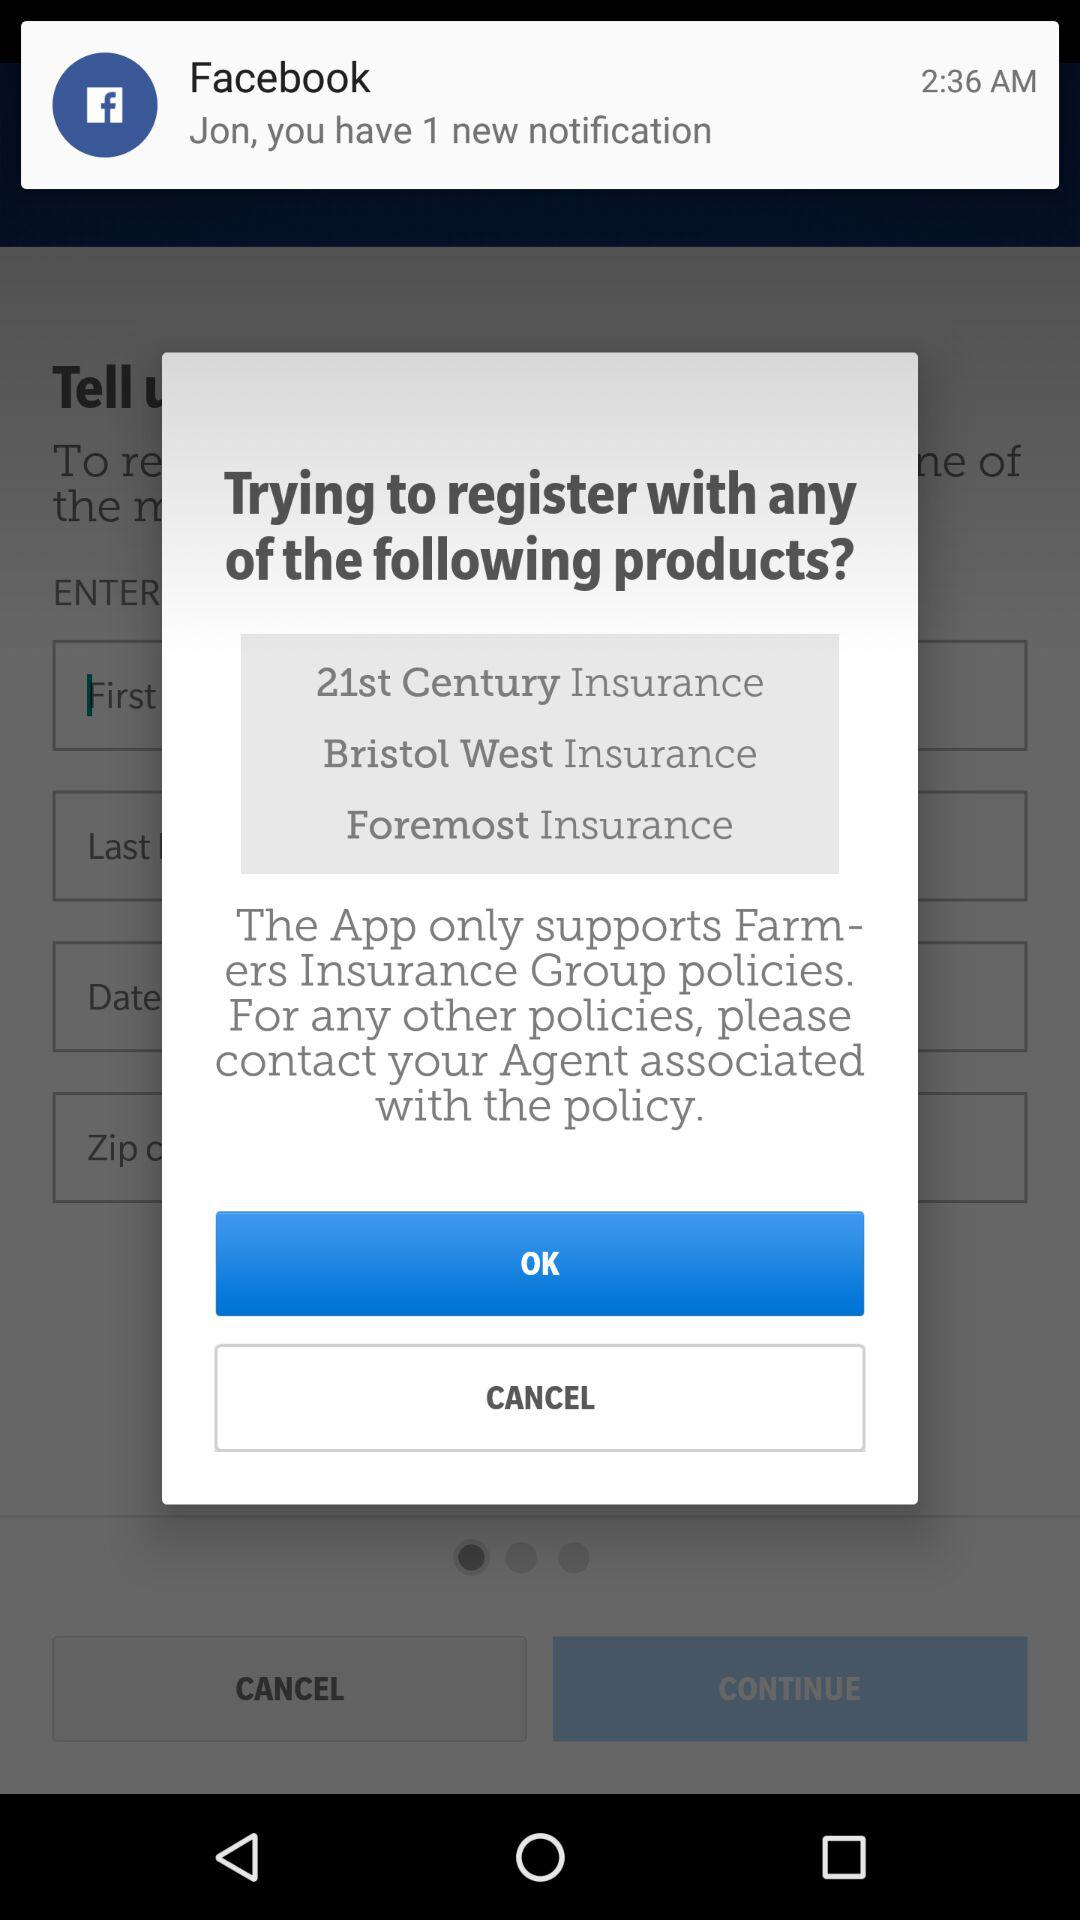What is the name of the user? The name of the user is Jon. 